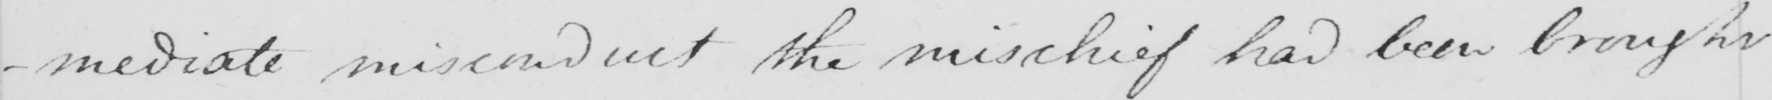Transcribe the text shown in this historical manuscript line. -mediate misconduct the mischief had been brought 